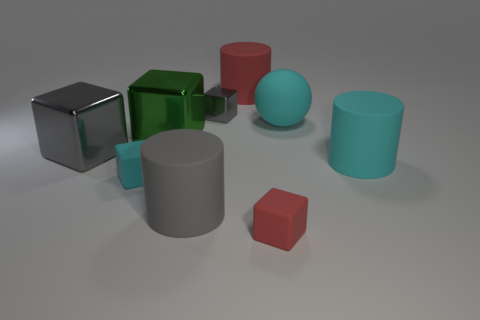Subtract all purple cylinders. How many gray cubes are left? 2 Subtract all large cyan rubber cylinders. How many cylinders are left? 2 Subtract all green cubes. How many cubes are left? 4 Subtract all blocks. How many objects are left? 4 Subtract all green cubes. Subtract all yellow cylinders. How many cubes are left? 4 Add 4 large yellow shiny balls. How many large yellow shiny balls exist? 4 Subtract 1 cyan balls. How many objects are left? 8 Subtract all big cyan cylinders. Subtract all large red cylinders. How many objects are left? 7 Add 4 large red rubber cylinders. How many large red rubber cylinders are left? 5 